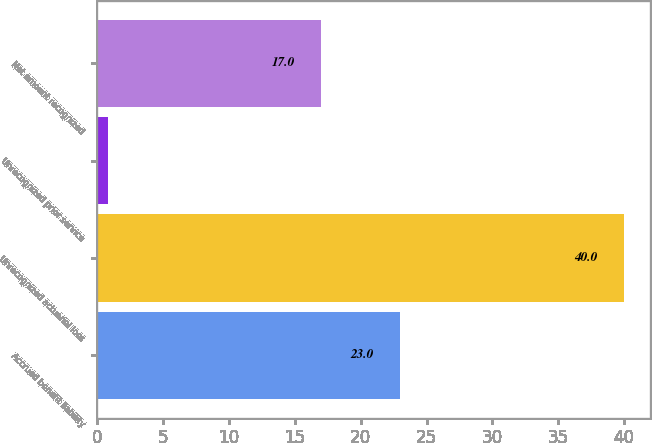<chart> <loc_0><loc_0><loc_500><loc_500><bar_chart><fcel>Accrued benefit liability<fcel>Unrecognized actuarial loss<fcel>Unrecognized prior service<fcel>Net amount recognized<nl><fcel>23<fcel>40<fcel>0.83<fcel>17<nl></chart> 